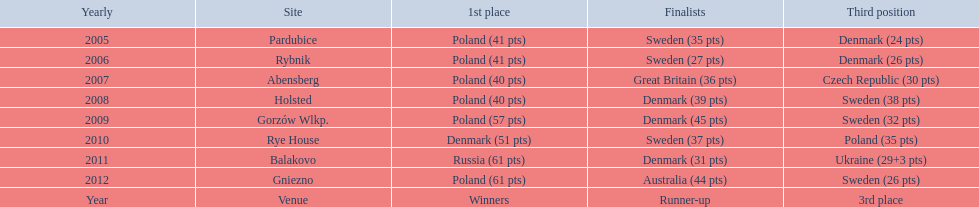Previous to 2008 how many times was sweden the runner up? 2. 